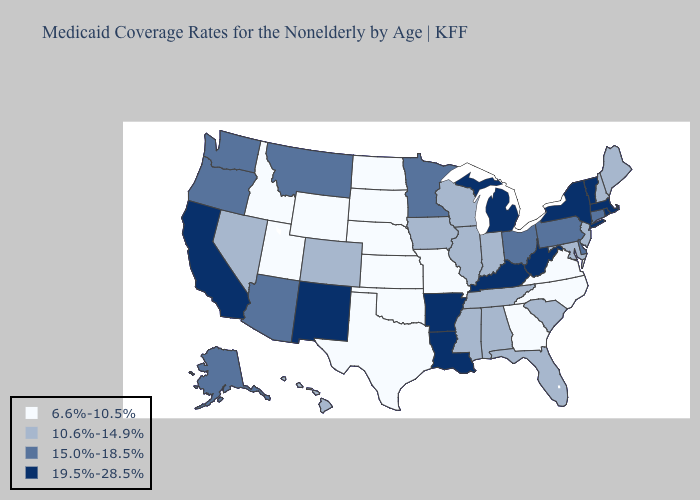Name the states that have a value in the range 19.5%-28.5%?
Give a very brief answer. Arkansas, California, Kentucky, Louisiana, Massachusetts, Michigan, New Mexico, New York, Rhode Island, Vermont, West Virginia. Which states have the highest value in the USA?
Keep it brief. Arkansas, California, Kentucky, Louisiana, Massachusetts, Michigan, New Mexico, New York, Rhode Island, Vermont, West Virginia. Among the states that border Wisconsin , does Iowa have the highest value?
Concise answer only. No. Which states have the highest value in the USA?
Concise answer only. Arkansas, California, Kentucky, Louisiana, Massachusetts, Michigan, New Mexico, New York, Rhode Island, Vermont, West Virginia. What is the value of Illinois?
Keep it brief. 10.6%-14.9%. Which states have the highest value in the USA?
Answer briefly. Arkansas, California, Kentucky, Louisiana, Massachusetts, Michigan, New Mexico, New York, Rhode Island, Vermont, West Virginia. Which states have the highest value in the USA?
Write a very short answer. Arkansas, California, Kentucky, Louisiana, Massachusetts, Michigan, New Mexico, New York, Rhode Island, Vermont, West Virginia. Among the states that border Mississippi , does Arkansas have the highest value?
Quick response, please. Yes. Which states have the lowest value in the West?
Keep it brief. Idaho, Utah, Wyoming. What is the lowest value in the USA?
Answer briefly. 6.6%-10.5%. Is the legend a continuous bar?
Answer briefly. No. Name the states that have a value in the range 19.5%-28.5%?
Quick response, please. Arkansas, California, Kentucky, Louisiana, Massachusetts, Michigan, New Mexico, New York, Rhode Island, Vermont, West Virginia. Among the states that border Missouri , does Oklahoma have the highest value?
Short answer required. No. What is the lowest value in states that border New Jersey?
Answer briefly. 15.0%-18.5%. Name the states that have a value in the range 10.6%-14.9%?
Answer briefly. Alabama, Colorado, Florida, Hawaii, Illinois, Indiana, Iowa, Maine, Maryland, Mississippi, Nevada, New Hampshire, New Jersey, South Carolina, Tennessee, Wisconsin. 